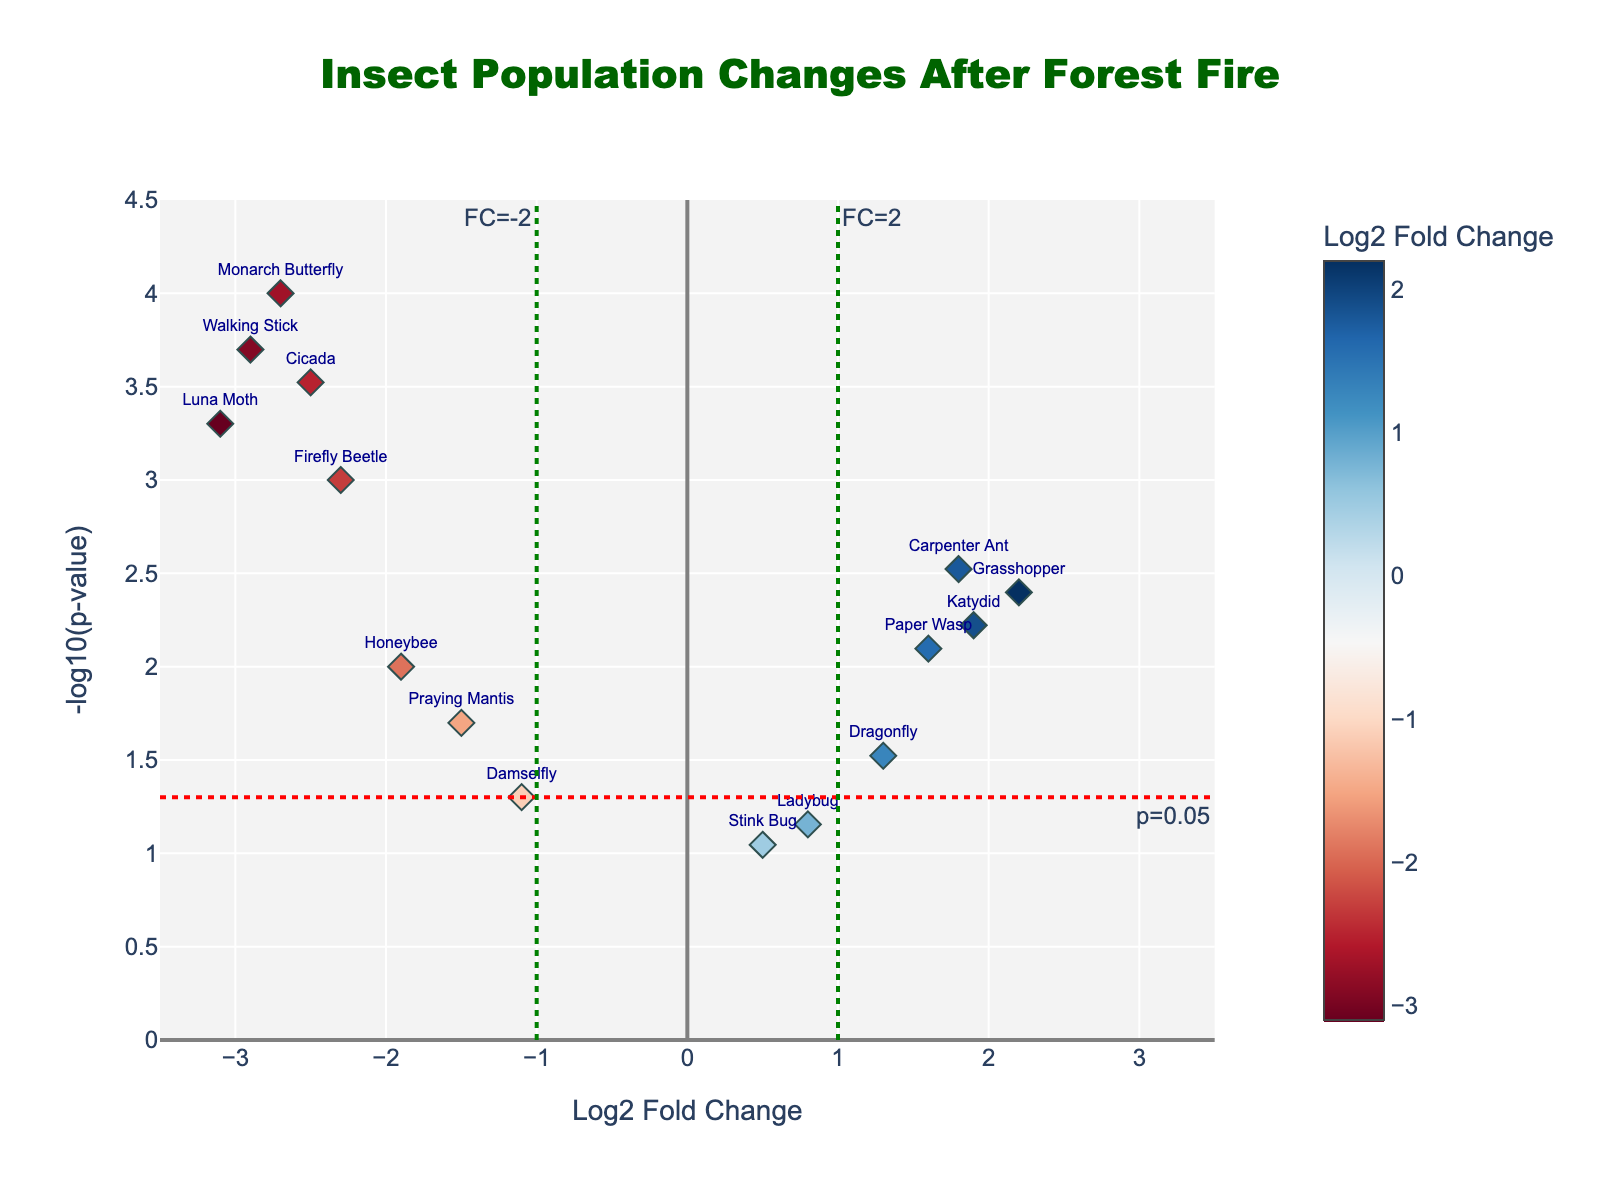What's the title of the plot? The title of the plot is usually prominently displayed at the top. In this case, it reads "Insect Population Changes After Forest Fire".
Answer: Insect Population Changes After Forest Fire What does the x-axis represent? The x-axis label is "Log2 Fold Change", indicating it represents the change in insect population diversity and abundance on a logarithmic scale (base 2).
Answer: Log2 Fold Change What does the y-axis represent? The y-axis label is "-log10(p-value)", indicating it represents the negative logarithm (base 10) of the p-values, which measure statistical significance.
Answer: -log10(p-value) How many species showed a significant change after the forest fire with a p-value less than 0.05? The threshold line for p-value is set at y = -log10(0.05). Significant species are those that appear above this line. Counting these, we have: Firefly Beetle, Carpenter Ant, Luna Moth, Monarch Butterfly, Grasshopper, Honeybee, Paper Wasp, Katydid, Cicada, and Walking Stick.
Answer: 10 Which species experienced the greatest decrease in population after the forest fire? The species with the lowest Log2 Fold Change indicate the greatest decrease. The Luna Moth has the most negative Log2 Fold Change at -3.1.
Answer: Luna Moth Which species experienced the greatest increase in population after the forest fire? The species with the highest Log2 Fold Change indicate the greatest increase. The Grasshopper has the highest Log2 Fold Change at 2.2.
Answer: Grasshopper Are there any species that did not show a statistically significant change in population (p-value >= 0.05)? Check species where the y-value (indicating -log10(p-value)) is below the threshold line. These are: Ladybug (p-value 0.07), Stink Bug (p-value 0.09), and Damselfly (p-value 0.05).
Answer: Ladybug, Stink Bug, Damselfly What is the Log2 Fold Change value and p-value for the Monarch Butterfly? By hovering over the data point labeled "Monarch Butterfly": Log2 Fold Change is -2.7 and the p-value is 0.0001.
Answer: Log2FC: -2.7, p-value: 0.0001 Which two species have the closest Log2 Fold Change values, one positive and one negative? By comparing the data points, we see Carpenter Ant and Paper Wasp share similar positive Log2 Fold Change values (1.8 and 1.6), while Firefly Beetle and Honeybee share similar negative values (-2.3 and -1.9). By proximity, Carpenter Ant and Firefly Beetle are closest with Log2FC values of 1.8 and -2.3.
Answer: Carpenter Ant and Firefly Beetle How many species have a Log2 Fold Change value greater than 1? Count the data points with x-values greater than 1: Carpenter Ant, Grasshopper, Paper Wasp, and Katydid.
Answer: 4 